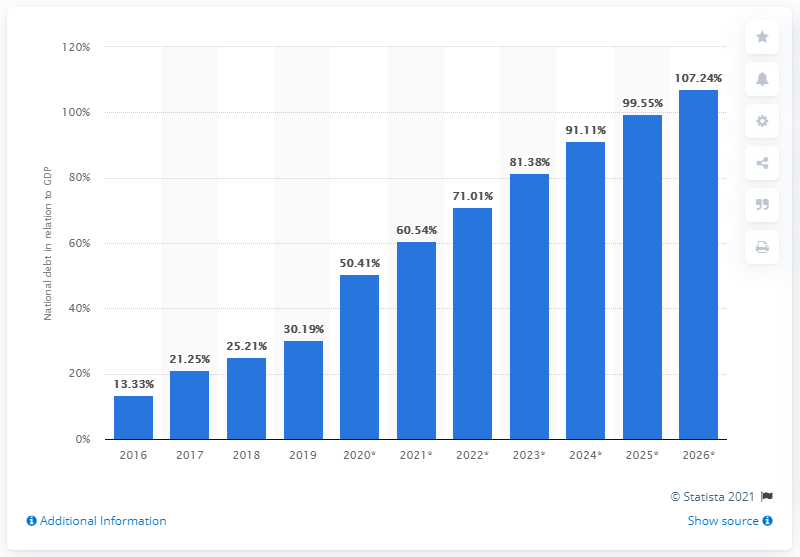Point out several critical features in this image. In 2019, the national debt of Algeria accounted for approximately 30.19% of the country's Gross Domestic Product (GDP). 